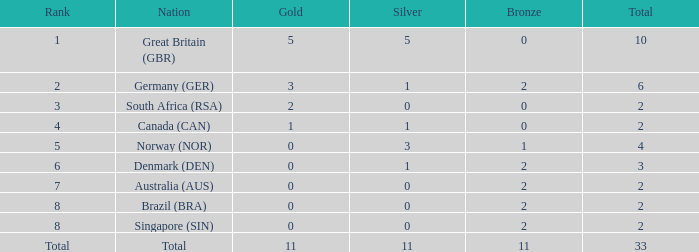What signifies bronze when the standing is third and the total surpasses 2? None. 